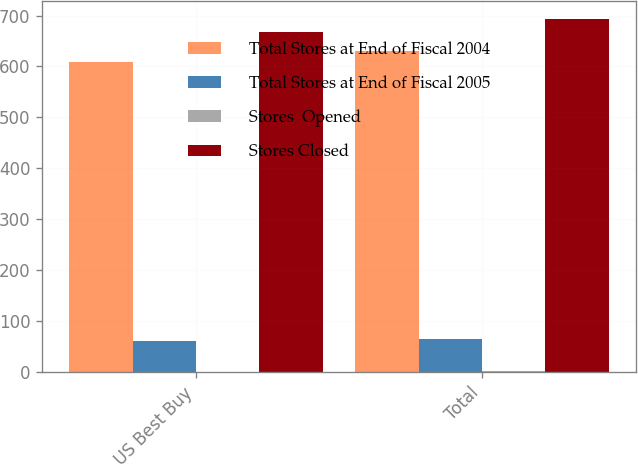Convert chart. <chart><loc_0><loc_0><loc_500><loc_500><stacked_bar_chart><ecel><fcel>US Best Buy<fcel>Total<nl><fcel>Total Stores at End of Fiscal 2004<fcel>608<fcel>631<nl><fcel>Total Stores at End of Fiscal 2005<fcel>61<fcel>66<nl><fcel>Stores  Opened<fcel>1<fcel>3<nl><fcel>Stores Closed<fcel>668<fcel>694<nl></chart> 